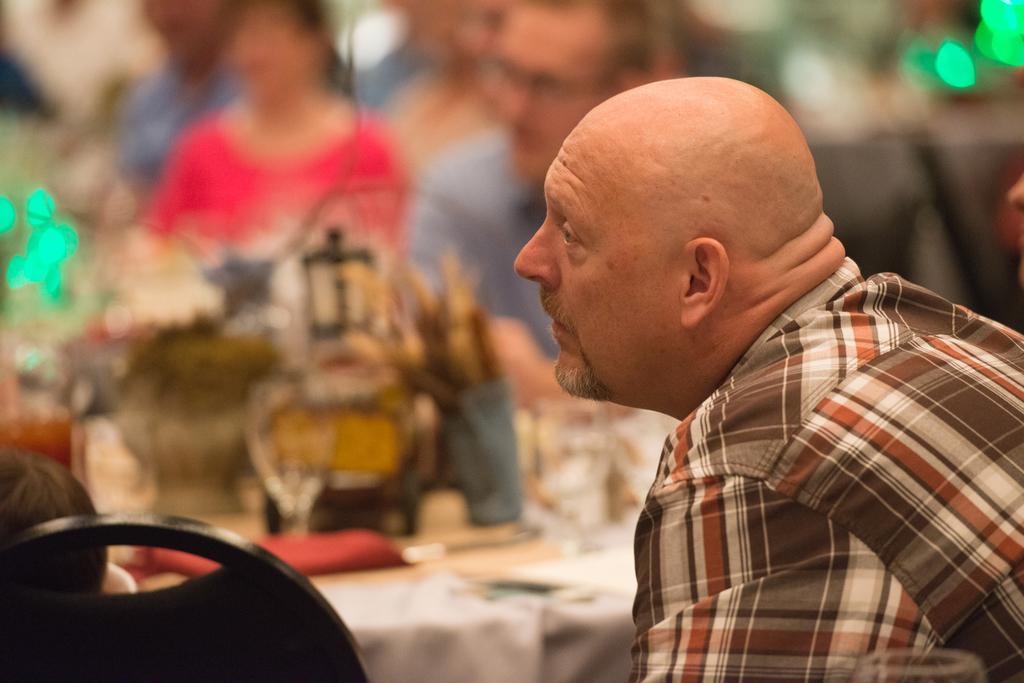Could you give a brief overview of what you see in this image? In this image we can see a person looking towards the left and we can also see the chair and lights. 